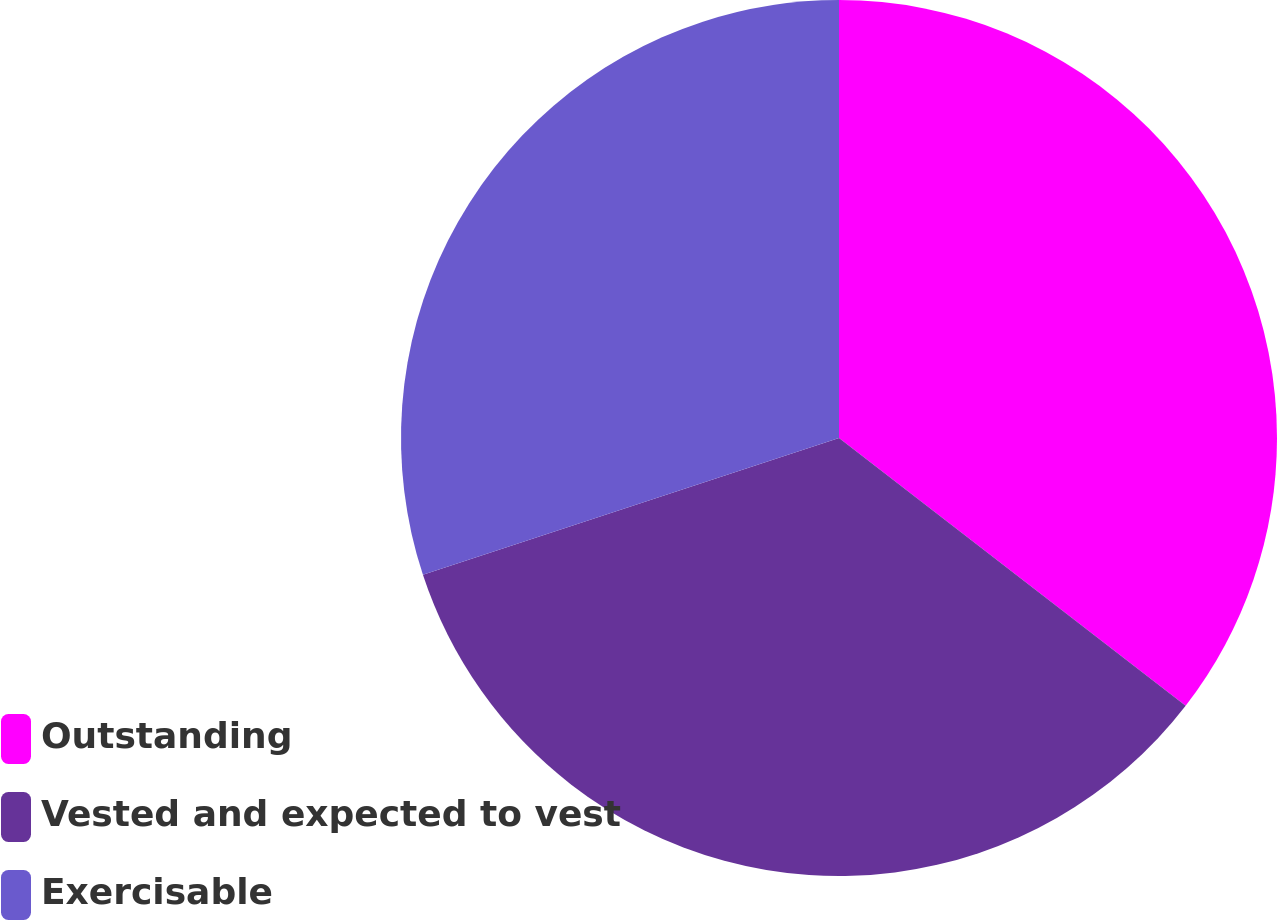<chart> <loc_0><loc_0><loc_500><loc_500><pie_chart><fcel>Outstanding<fcel>Vested and expected to vest<fcel>Exercisable<nl><fcel>35.47%<fcel>34.48%<fcel>30.06%<nl></chart> 